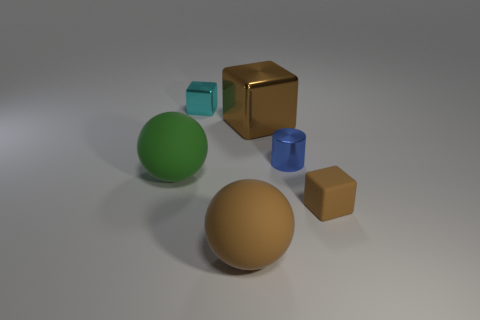Is there any other thing that has the same shape as the blue metallic object?
Offer a very short reply. No. What material is the big cube that is on the right side of the tiny object that is behind the big cube?
Your response must be concise. Metal. What is the size of the brown block right of the blue shiny cylinder?
Your answer should be very brief. Small. There is a rubber object that is on the left side of the blue shiny thing and in front of the big green matte sphere; what is its color?
Offer a terse response. Brown. Is the size of the block in front of the blue object the same as the brown metal thing?
Offer a terse response. No. Is there a small blue shiny object to the right of the matte ball that is to the left of the cyan shiny object?
Offer a very short reply. Yes. What is the material of the tiny brown block?
Give a very brief answer. Rubber. There is a brown rubber cube; are there any objects in front of it?
Give a very brief answer. Yes. What is the size of the other shiny object that is the same shape as the small cyan thing?
Offer a terse response. Large. Are there the same number of small brown matte blocks that are behind the big green rubber thing and big brown metal objects in front of the cylinder?
Ensure brevity in your answer.  Yes. 